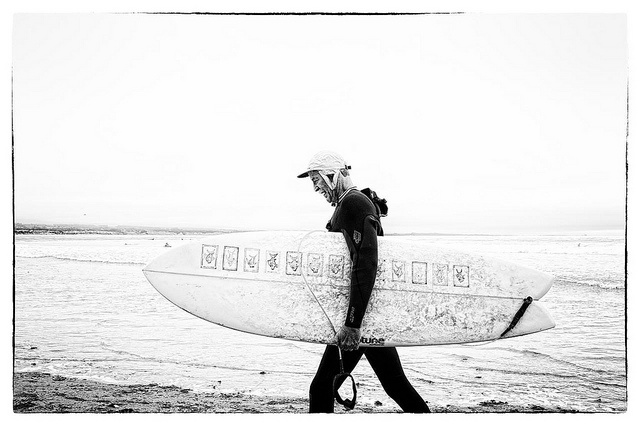Describe the objects in this image and their specific colors. I can see surfboard in white, lightgray, darkgray, gray, and black tones and people in white, black, lightgray, gray, and darkgray tones in this image. 